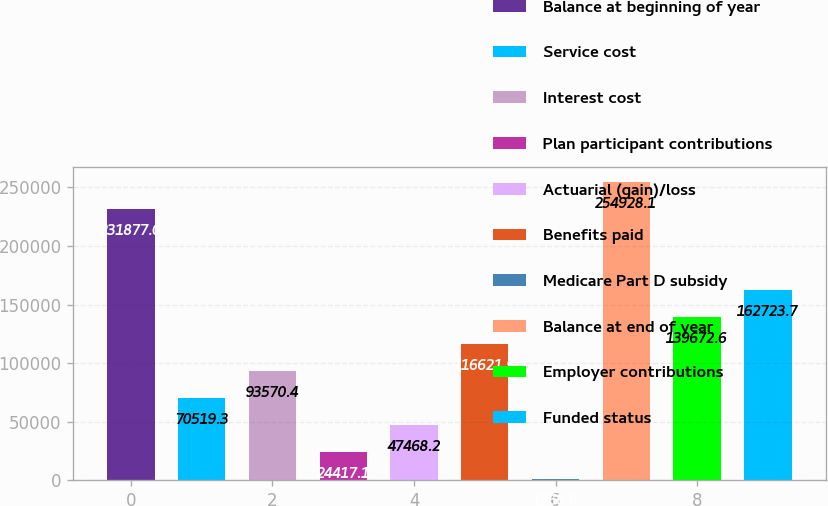Convert chart. <chart><loc_0><loc_0><loc_500><loc_500><bar_chart><fcel>Balance at beginning of year<fcel>Service cost<fcel>Interest cost<fcel>Plan participant contributions<fcel>Actuarial (gain)/loss<fcel>Benefits paid<fcel>Medicare Part D subsidy<fcel>Balance at end of year<fcel>Employer contributions<fcel>Funded status<nl><fcel>231877<fcel>70519.3<fcel>93570.4<fcel>24417.1<fcel>47468.2<fcel>116622<fcel>1366<fcel>254928<fcel>139673<fcel>162724<nl></chart> 